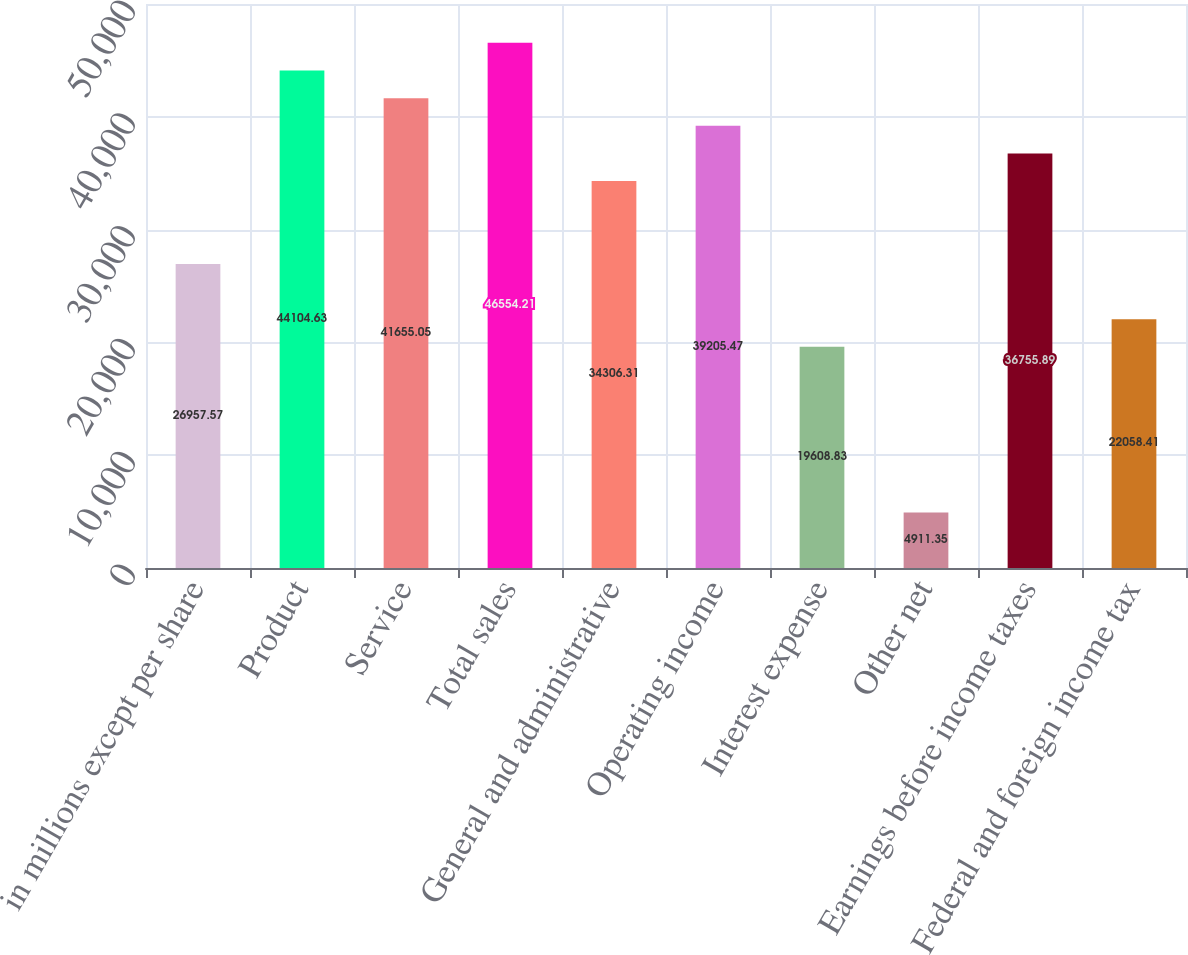<chart> <loc_0><loc_0><loc_500><loc_500><bar_chart><fcel>in millions except per share<fcel>Product<fcel>Service<fcel>Total sales<fcel>General and administrative<fcel>Operating income<fcel>Interest expense<fcel>Other net<fcel>Earnings before income taxes<fcel>Federal and foreign income tax<nl><fcel>26957.6<fcel>44104.6<fcel>41655.1<fcel>46554.2<fcel>34306.3<fcel>39205.5<fcel>19608.8<fcel>4911.35<fcel>36755.9<fcel>22058.4<nl></chart> 